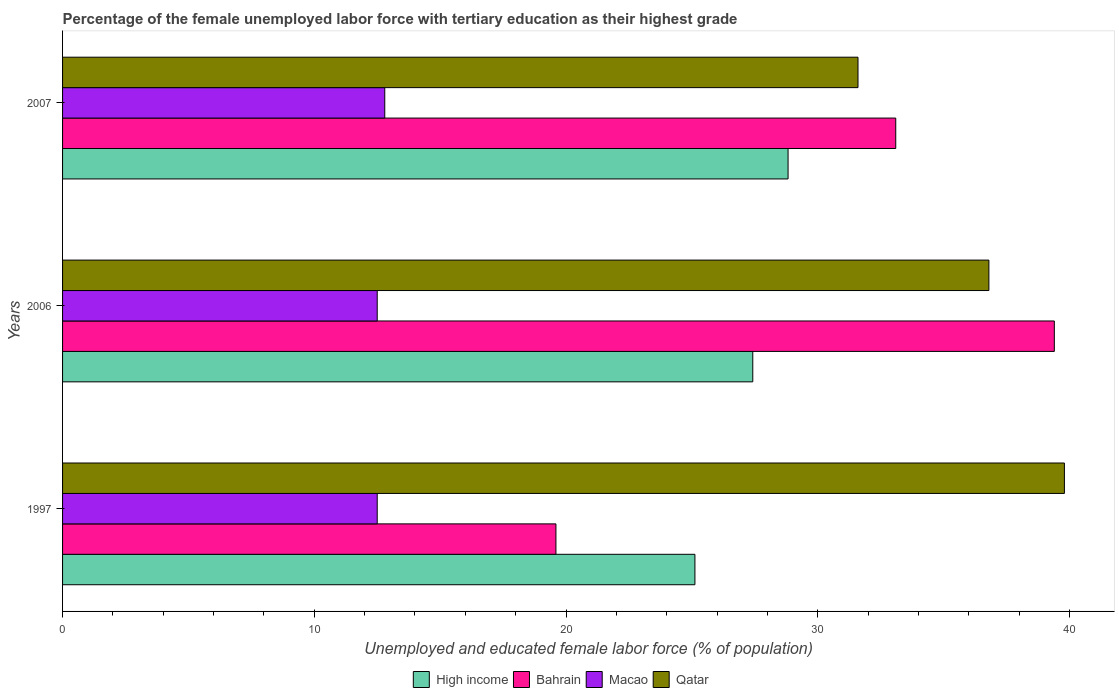How many groups of bars are there?
Keep it short and to the point. 3. Are the number of bars on each tick of the Y-axis equal?
Offer a terse response. Yes. How many bars are there on the 2nd tick from the top?
Offer a very short reply. 4. What is the label of the 1st group of bars from the top?
Your answer should be compact. 2007. What is the percentage of the unemployed female labor force with tertiary education in Qatar in 1997?
Provide a short and direct response. 39.8. Across all years, what is the maximum percentage of the unemployed female labor force with tertiary education in Qatar?
Provide a succinct answer. 39.8. Across all years, what is the minimum percentage of the unemployed female labor force with tertiary education in Macao?
Offer a terse response. 12.5. In which year was the percentage of the unemployed female labor force with tertiary education in Macao maximum?
Offer a terse response. 2007. What is the total percentage of the unemployed female labor force with tertiary education in High income in the graph?
Give a very brief answer. 81.36. What is the difference between the percentage of the unemployed female labor force with tertiary education in Qatar in 2006 and that in 2007?
Your answer should be very brief. 5.2. What is the difference between the percentage of the unemployed female labor force with tertiary education in Bahrain in 2006 and the percentage of the unemployed female labor force with tertiary education in Macao in 2007?
Make the answer very short. 26.6. What is the average percentage of the unemployed female labor force with tertiary education in Qatar per year?
Your answer should be very brief. 36.07. In the year 2006, what is the difference between the percentage of the unemployed female labor force with tertiary education in Macao and percentage of the unemployed female labor force with tertiary education in Qatar?
Give a very brief answer. -24.3. What is the ratio of the percentage of the unemployed female labor force with tertiary education in Macao in 1997 to that in 2006?
Keep it short and to the point. 1. What is the difference between the highest and the second highest percentage of the unemployed female labor force with tertiary education in Qatar?
Your response must be concise. 3. What is the difference between the highest and the lowest percentage of the unemployed female labor force with tertiary education in High income?
Offer a terse response. 3.7. Is the sum of the percentage of the unemployed female labor force with tertiary education in Bahrain in 2006 and 2007 greater than the maximum percentage of the unemployed female labor force with tertiary education in Macao across all years?
Provide a succinct answer. Yes. Is it the case that in every year, the sum of the percentage of the unemployed female labor force with tertiary education in High income and percentage of the unemployed female labor force with tertiary education in Macao is greater than the sum of percentage of the unemployed female labor force with tertiary education in Qatar and percentage of the unemployed female labor force with tertiary education in Bahrain?
Offer a terse response. No. What does the 1st bar from the top in 1997 represents?
Give a very brief answer. Qatar. What does the 2nd bar from the bottom in 2007 represents?
Keep it short and to the point. Bahrain. Where does the legend appear in the graph?
Provide a succinct answer. Bottom center. How many legend labels are there?
Your answer should be very brief. 4. How are the legend labels stacked?
Provide a succinct answer. Horizontal. What is the title of the graph?
Give a very brief answer. Percentage of the female unemployed labor force with tertiary education as their highest grade. Does "St. Kitts and Nevis" appear as one of the legend labels in the graph?
Your answer should be compact. No. What is the label or title of the X-axis?
Offer a very short reply. Unemployed and educated female labor force (% of population). What is the Unemployed and educated female labor force (% of population) of High income in 1997?
Provide a short and direct response. 25.12. What is the Unemployed and educated female labor force (% of population) of Bahrain in 1997?
Give a very brief answer. 19.6. What is the Unemployed and educated female labor force (% of population) of Macao in 1997?
Ensure brevity in your answer.  12.5. What is the Unemployed and educated female labor force (% of population) in Qatar in 1997?
Provide a short and direct response. 39.8. What is the Unemployed and educated female labor force (% of population) of High income in 2006?
Your answer should be compact. 27.42. What is the Unemployed and educated female labor force (% of population) of Bahrain in 2006?
Your response must be concise. 39.4. What is the Unemployed and educated female labor force (% of population) of Macao in 2006?
Your response must be concise. 12.5. What is the Unemployed and educated female labor force (% of population) in Qatar in 2006?
Provide a short and direct response. 36.8. What is the Unemployed and educated female labor force (% of population) of High income in 2007?
Ensure brevity in your answer.  28.82. What is the Unemployed and educated female labor force (% of population) in Bahrain in 2007?
Your answer should be compact. 33.1. What is the Unemployed and educated female labor force (% of population) of Macao in 2007?
Ensure brevity in your answer.  12.8. What is the Unemployed and educated female labor force (% of population) of Qatar in 2007?
Give a very brief answer. 31.6. Across all years, what is the maximum Unemployed and educated female labor force (% of population) in High income?
Your answer should be very brief. 28.82. Across all years, what is the maximum Unemployed and educated female labor force (% of population) of Bahrain?
Keep it short and to the point. 39.4. Across all years, what is the maximum Unemployed and educated female labor force (% of population) in Macao?
Keep it short and to the point. 12.8. Across all years, what is the maximum Unemployed and educated female labor force (% of population) of Qatar?
Provide a succinct answer. 39.8. Across all years, what is the minimum Unemployed and educated female labor force (% of population) of High income?
Provide a short and direct response. 25.12. Across all years, what is the minimum Unemployed and educated female labor force (% of population) in Bahrain?
Provide a short and direct response. 19.6. Across all years, what is the minimum Unemployed and educated female labor force (% of population) in Macao?
Offer a very short reply. 12.5. Across all years, what is the minimum Unemployed and educated female labor force (% of population) of Qatar?
Provide a succinct answer. 31.6. What is the total Unemployed and educated female labor force (% of population) of High income in the graph?
Make the answer very short. 81.36. What is the total Unemployed and educated female labor force (% of population) of Bahrain in the graph?
Make the answer very short. 92.1. What is the total Unemployed and educated female labor force (% of population) in Macao in the graph?
Provide a succinct answer. 37.8. What is the total Unemployed and educated female labor force (% of population) in Qatar in the graph?
Offer a terse response. 108.2. What is the difference between the Unemployed and educated female labor force (% of population) in High income in 1997 and that in 2006?
Provide a succinct answer. -2.3. What is the difference between the Unemployed and educated female labor force (% of population) in Bahrain in 1997 and that in 2006?
Keep it short and to the point. -19.8. What is the difference between the Unemployed and educated female labor force (% of population) in Macao in 1997 and that in 2006?
Provide a succinct answer. 0. What is the difference between the Unemployed and educated female labor force (% of population) of Qatar in 1997 and that in 2006?
Give a very brief answer. 3. What is the difference between the Unemployed and educated female labor force (% of population) of High income in 1997 and that in 2007?
Ensure brevity in your answer.  -3.7. What is the difference between the Unemployed and educated female labor force (% of population) in Macao in 1997 and that in 2007?
Provide a short and direct response. -0.3. What is the difference between the Unemployed and educated female labor force (% of population) in Qatar in 1997 and that in 2007?
Your answer should be very brief. 8.2. What is the difference between the Unemployed and educated female labor force (% of population) of High income in 2006 and that in 2007?
Your response must be concise. -1.4. What is the difference between the Unemployed and educated female labor force (% of population) in Bahrain in 2006 and that in 2007?
Your answer should be very brief. 6.3. What is the difference between the Unemployed and educated female labor force (% of population) of Macao in 2006 and that in 2007?
Keep it short and to the point. -0.3. What is the difference between the Unemployed and educated female labor force (% of population) of Qatar in 2006 and that in 2007?
Provide a short and direct response. 5.2. What is the difference between the Unemployed and educated female labor force (% of population) of High income in 1997 and the Unemployed and educated female labor force (% of population) of Bahrain in 2006?
Offer a very short reply. -14.28. What is the difference between the Unemployed and educated female labor force (% of population) in High income in 1997 and the Unemployed and educated female labor force (% of population) in Macao in 2006?
Ensure brevity in your answer.  12.62. What is the difference between the Unemployed and educated female labor force (% of population) in High income in 1997 and the Unemployed and educated female labor force (% of population) in Qatar in 2006?
Your answer should be compact. -11.68. What is the difference between the Unemployed and educated female labor force (% of population) of Bahrain in 1997 and the Unemployed and educated female labor force (% of population) of Qatar in 2006?
Your answer should be very brief. -17.2. What is the difference between the Unemployed and educated female labor force (% of population) of Macao in 1997 and the Unemployed and educated female labor force (% of population) of Qatar in 2006?
Make the answer very short. -24.3. What is the difference between the Unemployed and educated female labor force (% of population) of High income in 1997 and the Unemployed and educated female labor force (% of population) of Bahrain in 2007?
Provide a short and direct response. -7.98. What is the difference between the Unemployed and educated female labor force (% of population) in High income in 1997 and the Unemployed and educated female labor force (% of population) in Macao in 2007?
Offer a terse response. 12.32. What is the difference between the Unemployed and educated female labor force (% of population) in High income in 1997 and the Unemployed and educated female labor force (% of population) in Qatar in 2007?
Make the answer very short. -6.48. What is the difference between the Unemployed and educated female labor force (% of population) of Macao in 1997 and the Unemployed and educated female labor force (% of population) of Qatar in 2007?
Your answer should be very brief. -19.1. What is the difference between the Unemployed and educated female labor force (% of population) in High income in 2006 and the Unemployed and educated female labor force (% of population) in Bahrain in 2007?
Give a very brief answer. -5.68. What is the difference between the Unemployed and educated female labor force (% of population) in High income in 2006 and the Unemployed and educated female labor force (% of population) in Macao in 2007?
Ensure brevity in your answer.  14.62. What is the difference between the Unemployed and educated female labor force (% of population) of High income in 2006 and the Unemployed and educated female labor force (% of population) of Qatar in 2007?
Your response must be concise. -4.18. What is the difference between the Unemployed and educated female labor force (% of population) of Bahrain in 2006 and the Unemployed and educated female labor force (% of population) of Macao in 2007?
Your response must be concise. 26.6. What is the difference between the Unemployed and educated female labor force (% of population) of Bahrain in 2006 and the Unemployed and educated female labor force (% of population) of Qatar in 2007?
Your answer should be compact. 7.8. What is the difference between the Unemployed and educated female labor force (% of population) in Macao in 2006 and the Unemployed and educated female labor force (% of population) in Qatar in 2007?
Keep it short and to the point. -19.1. What is the average Unemployed and educated female labor force (% of population) in High income per year?
Your response must be concise. 27.12. What is the average Unemployed and educated female labor force (% of population) in Bahrain per year?
Your response must be concise. 30.7. What is the average Unemployed and educated female labor force (% of population) in Qatar per year?
Your answer should be very brief. 36.07. In the year 1997, what is the difference between the Unemployed and educated female labor force (% of population) of High income and Unemployed and educated female labor force (% of population) of Bahrain?
Your response must be concise. 5.52. In the year 1997, what is the difference between the Unemployed and educated female labor force (% of population) in High income and Unemployed and educated female labor force (% of population) in Macao?
Provide a succinct answer. 12.62. In the year 1997, what is the difference between the Unemployed and educated female labor force (% of population) in High income and Unemployed and educated female labor force (% of population) in Qatar?
Give a very brief answer. -14.68. In the year 1997, what is the difference between the Unemployed and educated female labor force (% of population) in Bahrain and Unemployed and educated female labor force (% of population) in Qatar?
Your answer should be compact. -20.2. In the year 1997, what is the difference between the Unemployed and educated female labor force (% of population) of Macao and Unemployed and educated female labor force (% of population) of Qatar?
Give a very brief answer. -27.3. In the year 2006, what is the difference between the Unemployed and educated female labor force (% of population) of High income and Unemployed and educated female labor force (% of population) of Bahrain?
Make the answer very short. -11.98. In the year 2006, what is the difference between the Unemployed and educated female labor force (% of population) of High income and Unemployed and educated female labor force (% of population) of Macao?
Offer a very short reply. 14.92. In the year 2006, what is the difference between the Unemployed and educated female labor force (% of population) of High income and Unemployed and educated female labor force (% of population) of Qatar?
Your answer should be compact. -9.38. In the year 2006, what is the difference between the Unemployed and educated female labor force (% of population) in Bahrain and Unemployed and educated female labor force (% of population) in Macao?
Offer a very short reply. 26.9. In the year 2006, what is the difference between the Unemployed and educated female labor force (% of population) of Bahrain and Unemployed and educated female labor force (% of population) of Qatar?
Your response must be concise. 2.6. In the year 2006, what is the difference between the Unemployed and educated female labor force (% of population) in Macao and Unemployed and educated female labor force (% of population) in Qatar?
Provide a short and direct response. -24.3. In the year 2007, what is the difference between the Unemployed and educated female labor force (% of population) in High income and Unemployed and educated female labor force (% of population) in Bahrain?
Your answer should be compact. -4.28. In the year 2007, what is the difference between the Unemployed and educated female labor force (% of population) of High income and Unemployed and educated female labor force (% of population) of Macao?
Make the answer very short. 16.02. In the year 2007, what is the difference between the Unemployed and educated female labor force (% of population) in High income and Unemployed and educated female labor force (% of population) in Qatar?
Your answer should be compact. -2.78. In the year 2007, what is the difference between the Unemployed and educated female labor force (% of population) of Bahrain and Unemployed and educated female labor force (% of population) of Macao?
Make the answer very short. 20.3. In the year 2007, what is the difference between the Unemployed and educated female labor force (% of population) of Bahrain and Unemployed and educated female labor force (% of population) of Qatar?
Offer a very short reply. 1.5. In the year 2007, what is the difference between the Unemployed and educated female labor force (% of population) in Macao and Unemployed and educated female labor force (% of population) in Qatar?
Your answer should be very brief. -18.8. What is the ratio of the Unemployed and educated female labor force (% of population) of High income in 1997 to that in 2006?
Offer a terse response. 0.92. What is the ratio of the Unemployed and educated female labor force (% of population) of Bahrain in 1997 to that in 2006?
Keep it short and to the point. 0.5. What is the ratio of the Unemployed and educated female labor force (% of population) of Macao in 1997 to that in 2006?
Your answer should be compact. 1. What is the ratio of the Unemployed and educated female labor force (% of population) of Qatar in 1997 to that in 2006?
Provide a short and direct response. 1.08. What is the ratio of the Unemployed and educated female labor force (% of population) of High income in 1997 to that in 2007?
Make the answer very short. 0.87. What is the ratio of the Unemployed and educated female labor force (% of population) in Bahrain in 1997 to that in 2007?
Your answer should be compact. 0.59. What is the ratio of the Unemployed and educated female labor force (% of population) in Macao in 1997 to that in 2007?
Provide a short and direct response. 0.98. What is the ratio of the Unemployed and educated female labor force (% of population) in Qatar in 1997 to that in 2007?
Offer a very short reply. 1.26. What is the ratio of the Unemployed and educated female labor force (% of population) in High income in 2006 to that in 2007?
Give a very brief answer. 0.95. What is the ratio of the Unemployed and educated female labor force (% of population) in Bahrain in 2006 to that in 2007?
Provide a short and direct response. 1.19. What is the ratio of the Unemployed and educated female labor force (% of population) in Macao in 2006 to that in 2007?
Your answer should be compact. 0.98. What is the ratio of the Unemployed and educated female labor force (% of population) in Qatar in 2006 to that in 2007?
Provide a succinct answer. 1.16. What is the difference between the highest and the second highest Unemployed and educated female labor force (% of population) of High income?
Give a very brief answer. 1.4. What is the difference between the highest and the second highest Unemployed and educated female labor force (% of population) in Macao?
Your answer should be very brief. 0.3. What is the difference between the highest and the lowest Unemployed and educated female labor force (% of population) of High income?
Keep it short and to the point. 3.7. What is the difference between the highest and the lowest Unemployed and educated female labor force (% of population) of Bahrain?
Your response must be concise. 19.8. What is the difference between the highest and the lowest Unemployed and educated female labor force (% of population) of Qatar?
Provide a short and direct response. 8.2. 